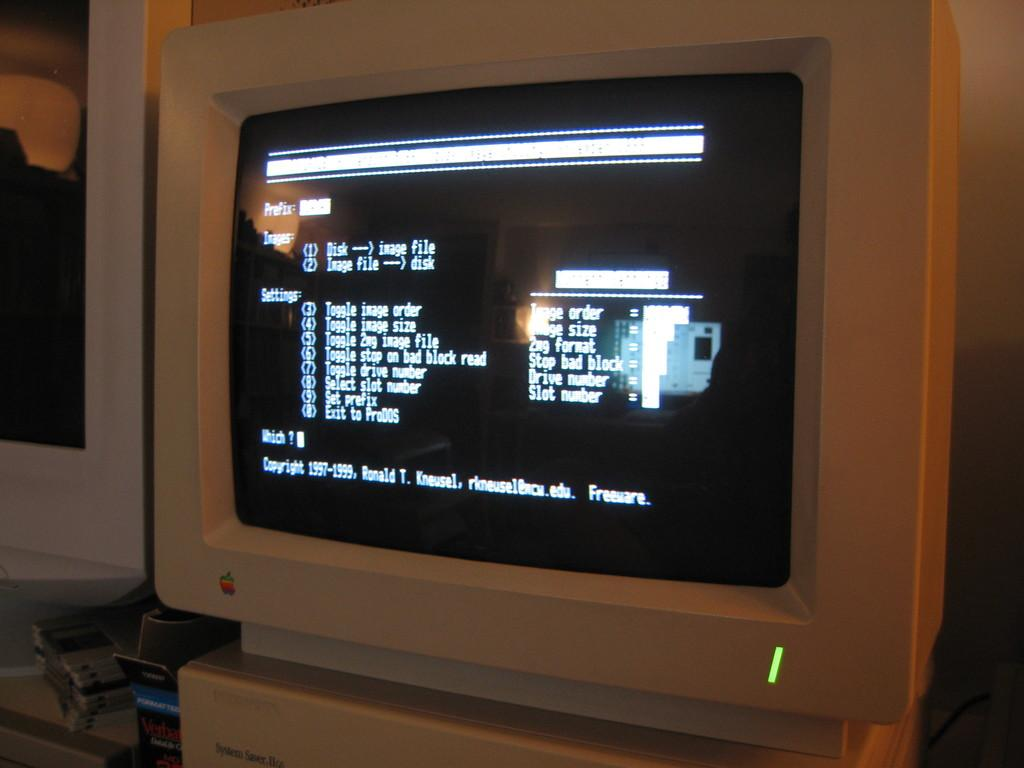What electronic device can be seen in the image? There is a monitor in the image. What is displayed on the monitor? Text is visible on the monitor. What is located beside the monitor? There is a packet beside the monitor. Can you describe any other objects in the image? There are other unspecified objects in the image. What type of frogs are depicted in the religious text on the monitor? There are no frogs or religious text present in the image. The monitor displays text, but it is not specified as religious or containing any images of frogs. 